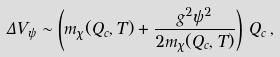Convert formula to latex. <formula><loc_0><loc_0><loc_500><loc_500>\Delta V _ { \psi } \sim \left ( m _ { \chi } ( Q _ { c } , T ) + \frac { g ^ { 2 } \psi ^ { 2 } } { 2 m _ { \chi } ( Q _ { c } , T ) } \right ) \, Q _ { c } \, ,</formula> 